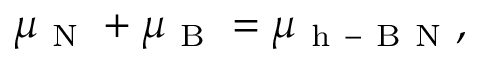Convert formula to latex. <formula><loc_0><loc_0><loc_500><loc_500>\mu _ { N } + \mu _ { B } = \mu _ { h - B N } ,</formula> 